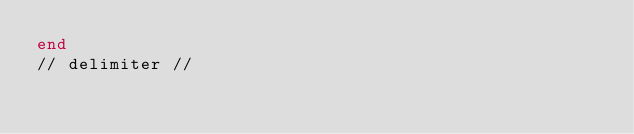Convert code to text. <code><loc_0><loc_0><loc_500><loc_500><_SQL_>end
// delimiter //</code> 